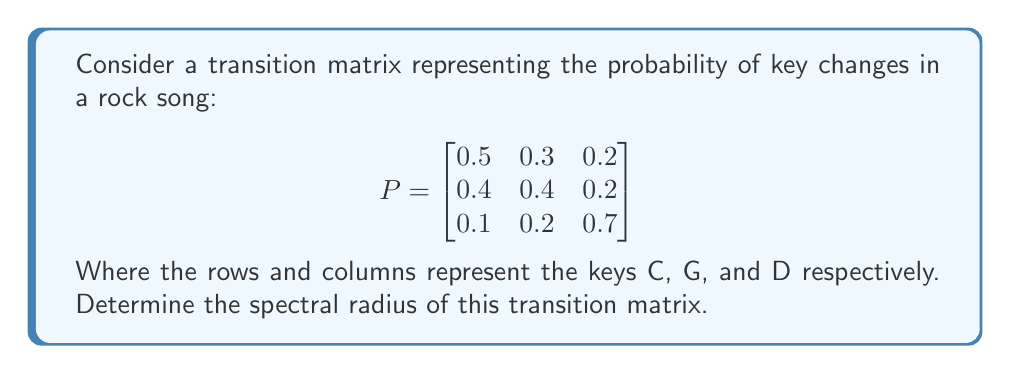Give your solution to this math problem. To find the spectral radius of the transition matrix P, we need to follow these steps:

1. Calculate the characteristic polynomial of P:
   $det(P - \lambda I) = 0$

   $$\begin{vmatrix}
   0.5-\lambda & 0.3 & 0.2 \\
   0.4 & 0.4-\lambda & 0.2 \\
   0.1 & 0.2 & 0.7-\lambda
   \end{vmatrix} = 0$$

2. Expand the determinant:
   $(0.5-\lambda)[(0.4-\lambda)(0.7-\lambda) - 0.04] - 0.3[0.4(0.7-\lambda) - 0.02] + 0.2[0.4(0.2) - 0.1(0.4-\lambda)] = 0$

3. Simplify:
   $-\lambda^3 + 1.6\lambda^2 - 0.71\lambda + 0.1 = 0$

4. Find the roots of this cubic equation. These are the eigenvalues of P.
   Using a numerical method or a calculator, we get:
   $\lambda_1 \approx 1$
   $\lambda_2 \approx 0.4472$
   $\lambda_3 \approx 0.1528$

5. The spectral radius is the maximum absolute value of the eigenvalues:
   $\rho(P) = \max(|\lambda_1|, |\lambda_2|, |\lambda_3|) = \max(1, 0.4472, 0.1528) = 1$

Note: The spectral radius is 1, which is expected for a stochastic matrix (transition probabilities in each row sum to 1).
Answer: 1 